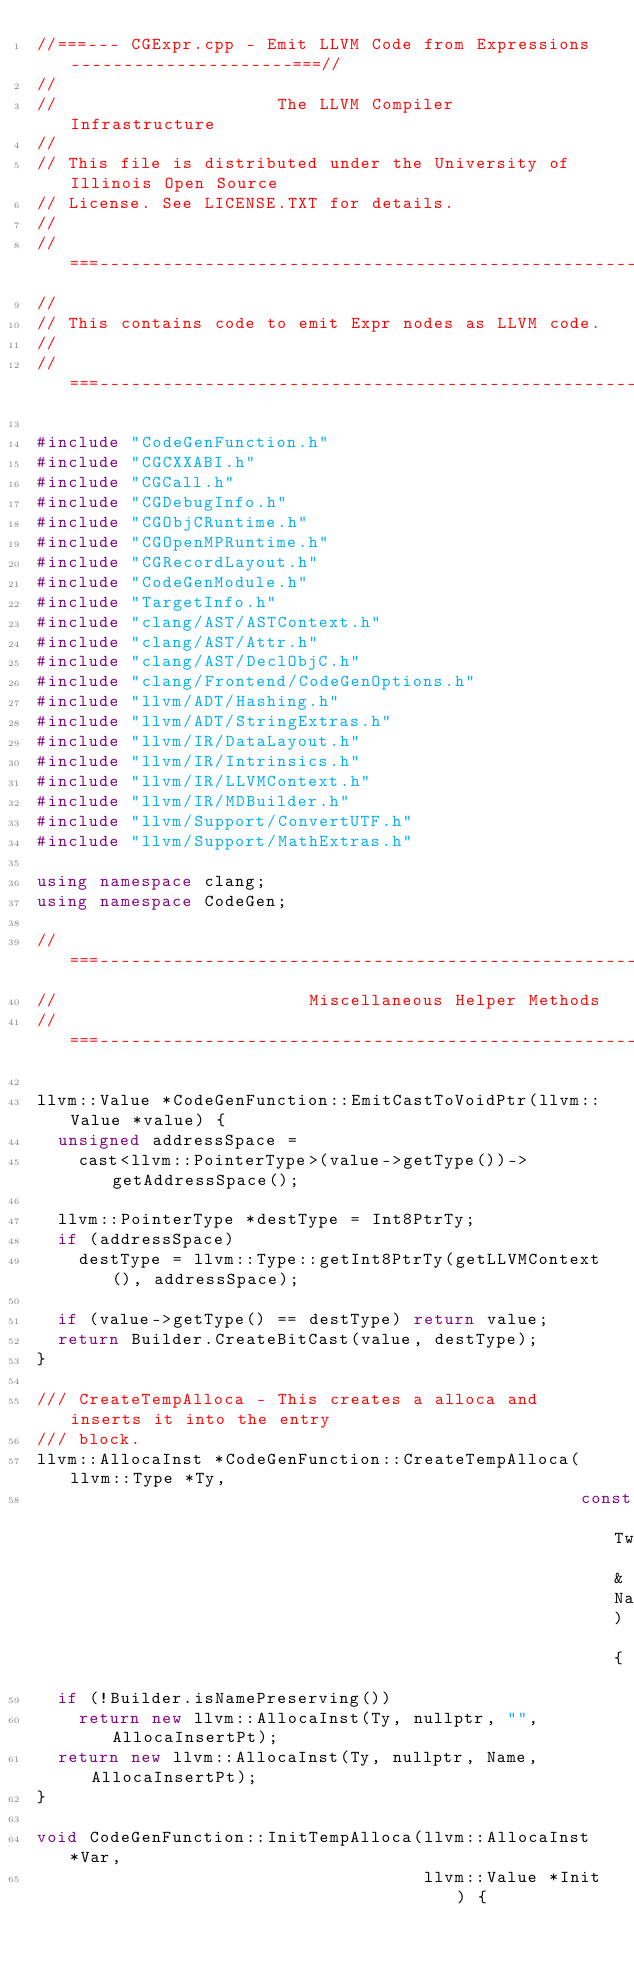Convert code to text. <code><loc_0><loc_0><loc_500><loc_500><_C++_>//===--- CGExpr.cpp - Emit LLVM Code from Expressions ---------------------===//
//
//                     The LLVM Compiler Infrastructure
//
// This file is distributed under the University of Illinois Open Source
// License. See LICENSE.TXT for details.
//
//===----------------------------------------------------------------------===//
//
// This contains code to emit Expr nodes as LLVM code.
//
//===----------------------------------------------------------------------===//

#include "CodeGenFunction.h"
#include "CGCXXABI.h"
#include "CGCall.h"
#include "CGDebugInfo.h"
#include "CGObjCRuntime.h"
#include "CGOpenMPRuntime.h"
#include "CGRecordLayout.h"
#include "CodeGenModule.h"
#include "TargetInfo.h"
#include "clang/AST/ASTContext.h"
#include "clang/AST/Attr.h"
#include "clang/AST/DeclObjC.h"
#include "clang/Frontend/CodeGenOptions.h"
#include "llvm/ADT/Hashing.h"
#include "llvm/ADT/StringExtras.h"
#include "llvm/IR/DataLayout.h"
#include "llvm/IR/Intrinsics.h"
#include "llvm/IR/LLVMContext.h"
#include "llvm/IR/MDBuilder.h"
#include "llvm/Support/ConvertUTF.h"
#include "llvm/Support/MathExtras.h"

using namespace clang;
using namespace CodeGen;

//===--------------------------------------------------------------------===//
//                        Miscellaneous Helper Methods
//===--------------------------------------------------------------------===//

llvm::Value *CodeGenFunction::EmitCastToVoidPtr(llvm::Value *value) {
  unsigned addressSpace =
    cast<llvm::PointerType>(value->getType())->getAddressSpace();

  llvm::PointerType *destType = Int8PtrTy;
  if (addressSpace)
    destType = llvm::Type::getInt8PtrTy(getLLVMContext(), addressSpace);

  if (value->getType() == destType) return value;
  return Builder.CreateBitCast(value, destType);
}

/// CreateTempAlloca - This creates a alloca and inserts it into the entry
/// block.
llvm::AllocaInst *CodeGenFunction::CreateTempAlloca(llvm::Type *Ty,
                                                    const Twine &Name) {
  if (!Builder.isNamePreserving())
    return new llvm::AllocaInst(Ty, nullptr, "", AllocaInsertPt);
  return new llvm::AllocaInst(Ty, nullptr, Name, AllocaInsertPt);
}

void CodeGenFunction::InitTempAlloca(llvm::AllocaInst *Var,
                                     llvm::Value *Init) {</code> 